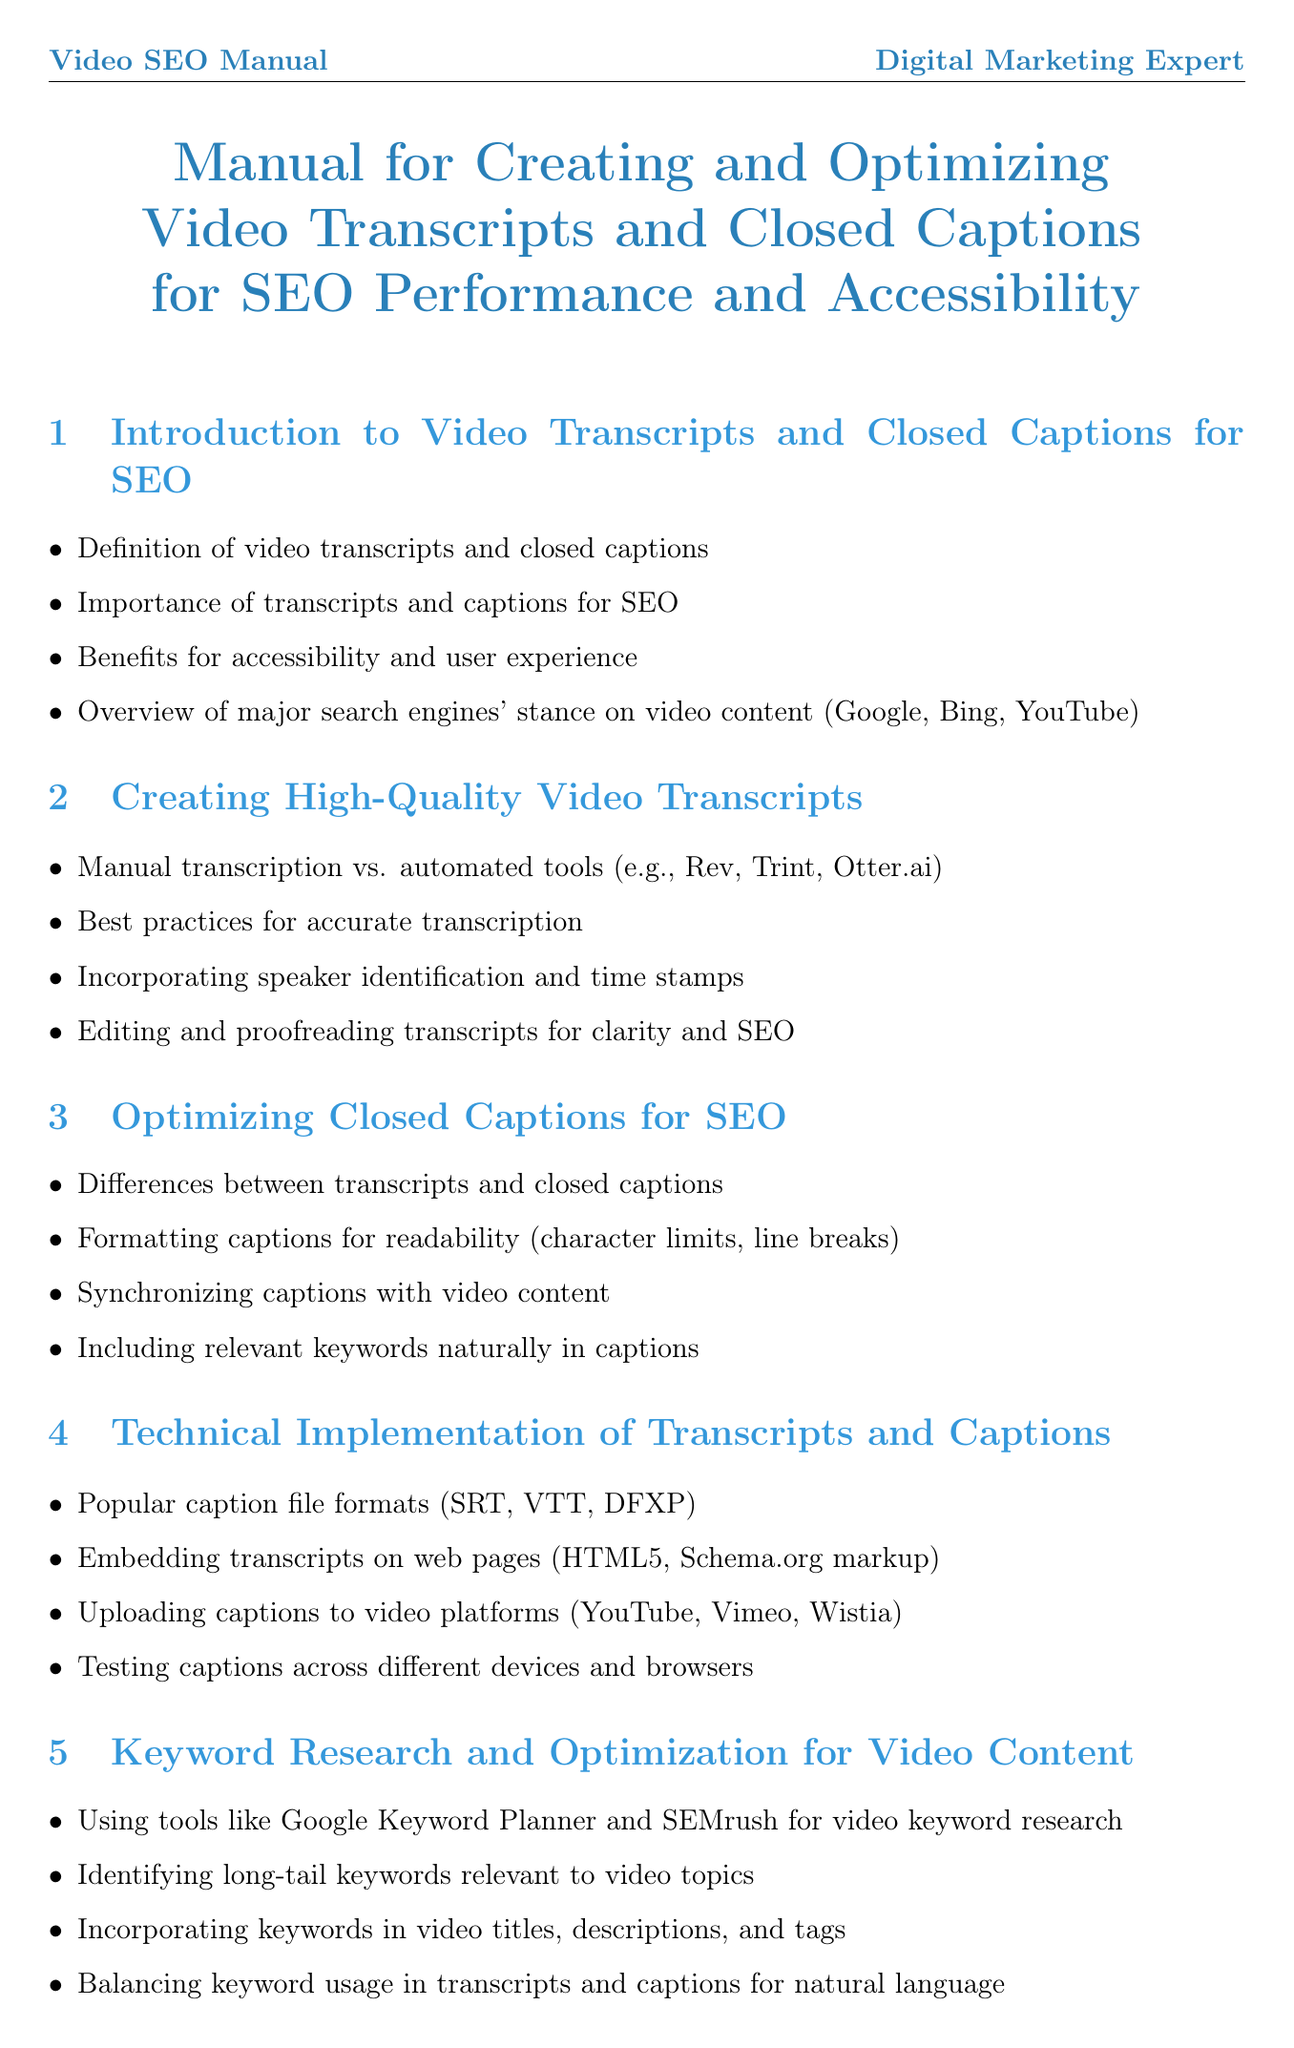What is the main purpose of video transcripts and closed captions? The main purpose is to boost SEO performance and accessibility.
Answer: boost SEO performance and accessibility Which tools can be used for automated transcription? The document lists examples such as Rev, Trint, Otter.ai.
Answer: Rev, Trint, Otter.ai What is the recommended method for ensuring accurate transcription? Best practices for accurate transcription are outlined in the manual.
Answer: Best practices for accurate transcription Which file formats are mentioned for captions? Popular caption file formats highlighted include SRT, VTT, and DFXP.
Answer: SRT, VTT, DFXP What guidelines should be met for video accessibility? WCAG 2.1 guidelines are specified in the document.
Answer: WCAG 2.1 What keyword research tools are suggested in the manual? Tools mentioned include Google Keyword Planner and SEMrush.
Answer: Google Keyword Planner and SEMrush How can video title optimization benefit SEO? The manual explains how optimizing video titles enhances search engine visibility.
Answer: enhances search engine visibility What is one advanced SEO technique for video content? One advanced technique is leveraging structured data markup for videos.
Answer: leveraging structured data markup for videos What does A/B testing provide insights into? It helps analyze transcript and caption variations for SEO improvement.
Answer: for SEO improvement 